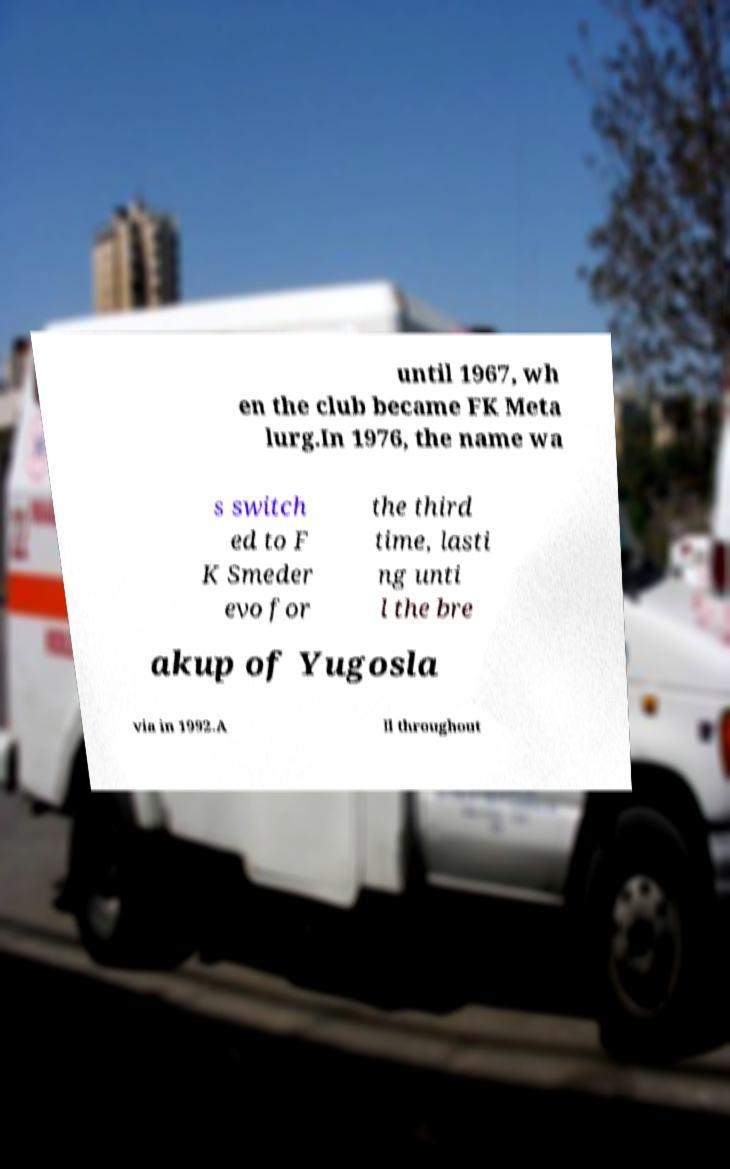Could you assist in decoding the text presented in this image and type it out clearly? until 1967, wh en the club became FK Meta lurg.In 1976, the name wa s switch ed to F K Smeder evo for the third time, lasti ng unti l the bre akup of Yugosla via in 1992.A ll throughout 